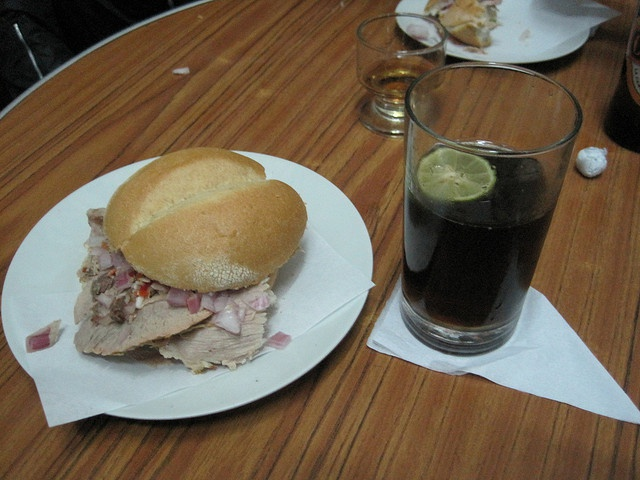Describe the objects in this image and their specific colors. I can see dining table in maroon, lightblue, black, and darkgray tones, cup in black, maroon, and gray tones, sandwich in black, tan, darkgray, olive, and gray tones, wine glass in black, maroon, gray, and darkgray tones, and cup in black, maroon, and gray tones in this image. 